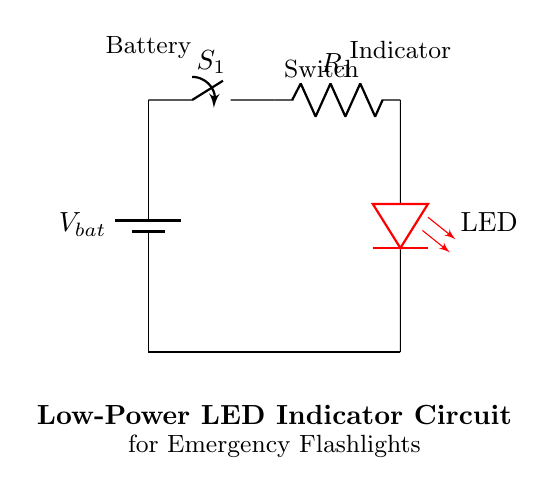What type of indicator is used in this circuit? The circuit uses an LED as the indicator, identified clearly in the diagram where it is labeled as "LED".
Answer: LED What is the role of the switch in this circuit? The switch controls the flow of current from the battery to the LED, allowing it to be turned on or off when the switch is closed or opened respectively.
Answer: Control What is the purpose of the resistor in the circuit? The resistor limits the current flowing through the LED to prevent it from drawing too much current, which could damage the LED.
Answer: Limit current What happens if the switch is open? If the switch is open, the circuit is incomplete, preventing any current from flowing to the LED, which means the LED will not light up.
Answer: No light How is the battery connected in this circuit? The battery is connected in series with the switch and the rest of the components, providing the necessary voltage to power the LED when the switch is closed.
Answer: Series What would happen to the LED if there was no resistor in the circuit? Without the resistor, the LED would likely draw too much current when powered, which could lead to overheating and failure of the LED due to excessive current.
Answer: Damage 